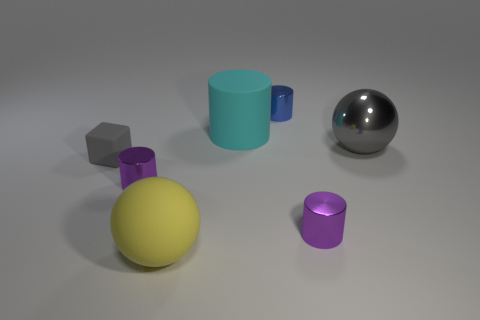Are there any other things that are the same shape as the small gray rubber object?
Your answer should be compact. No. Are there more cyan cylinders than tiny things?
Make the answer very short. No. What is the small blue cylinder made of?
Give a very brief answer. Metal. There is a purple shiny cylinder left of the big yellow sphere; what number of shiny things are right of it?
Ensure brevity in your answer.  3. There is a tiny block; is it the same color as the large sphere to the right of the small blue cylinder?
Keep it short and to the point. Yes. There is a cylinder that is the same size as the yellow sphere; what color is it?
Make the answer very short. Cyan. Are there any other rubber things of the same shape as the small gray rubber object?
Provide a short and direct response. No. Is the number of yellow matte things less than the number of large green things?
Offer a terse response. No. What is the color of the metal cylinder that is behind the small block?
Your response must be concise. Blue. What shape is the tiny purple shiny object to the left of the rubber thing that is in front of the rubber cube?
Give a very brief answer. Cylinder. 